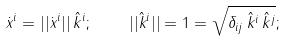<formula> <loc_0><loc_0><loc_500><loc_500>\dot { x } ^ { i } = | | \dot { x } ^ { i } | | \, \hat { k } ^ { i } ; \quad | | \hat { k } ^ { i } | | = 1 = \sqrt { \delta _ { i j } \, \hat { k } ^ { i } \, \hat { k } ^ { j } } ;</formula> 